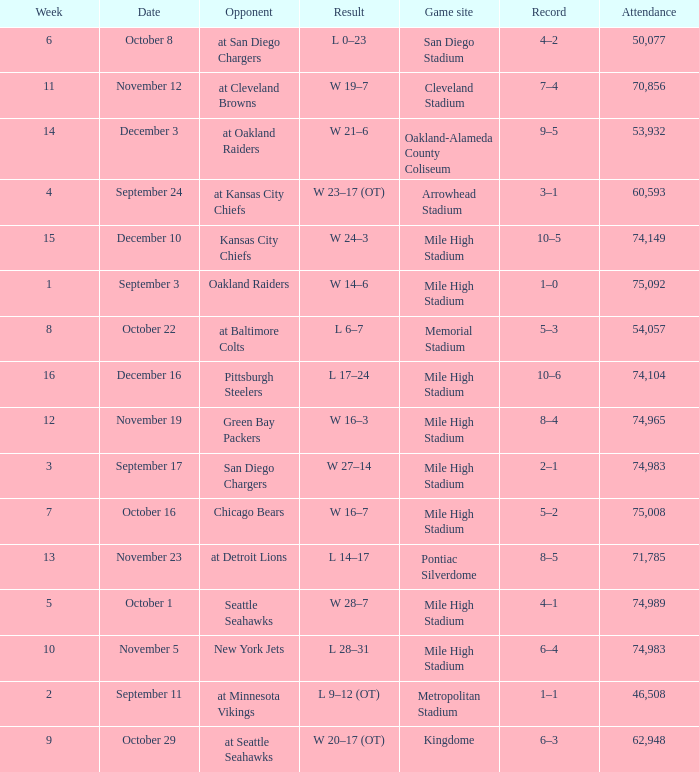During which week was there a 5-2 win-loss record? 7.0. 